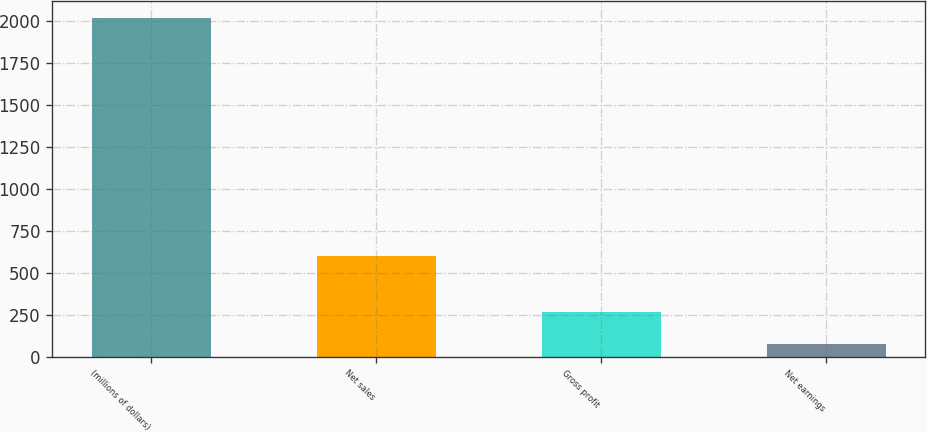Convert chart to OTSL. <chart><loc_0><loc_0><loc_500><loc_500><bar_chart><fcel>(millions of dollars)<fcel>Net sales<fcel>Gross profit<fcel>Net earnings<nl><fcel>2016<fcel>601.8<fcel>266.13<fcel>71.7<nl></chart> 